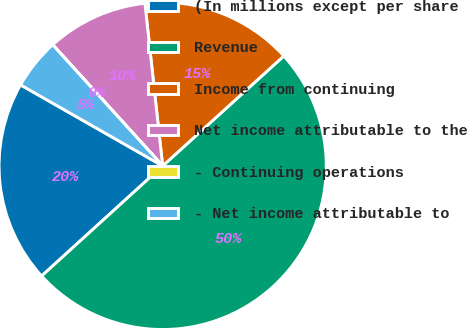<chart> <loc_0><loc_0><loc_500><loc_500><pie_chart><fcel>(In millions except per share<fcel>Revenue<fcel>Income from continuing<fcel>Net income attributable to the<fcel>- Continuing operations<fcel>- Net income attributable to<nl><fcel>20.0%<fcel>49.98%<fcel>15.0%<fcel>10.0%<fcel>0.01%<fcel>5.01%<nl></chart> 